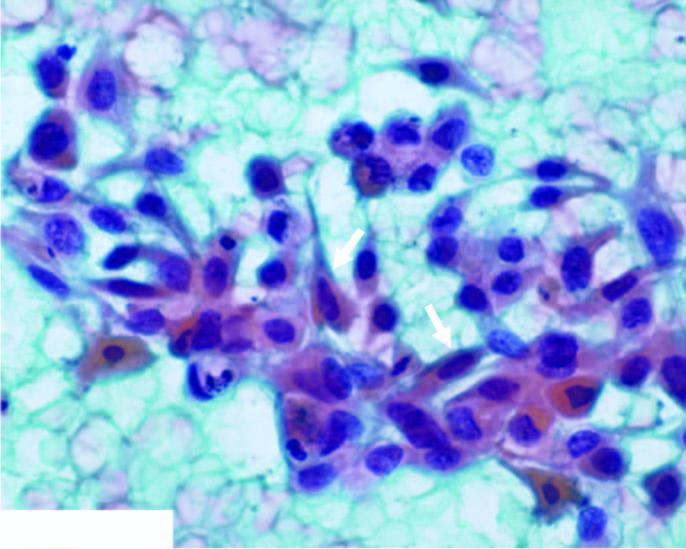re the tubular epithelial cells also seen?
Answer the question using a single word or phrase. No 